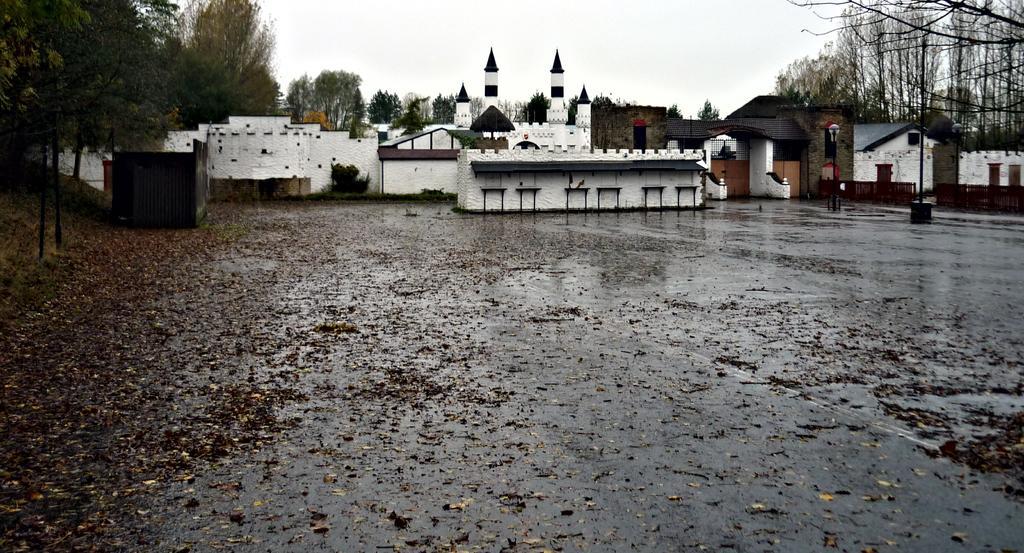Please provide a concise description of this image. In the image we can see there are buildings and trees and the ground is covered with dry leaves. 